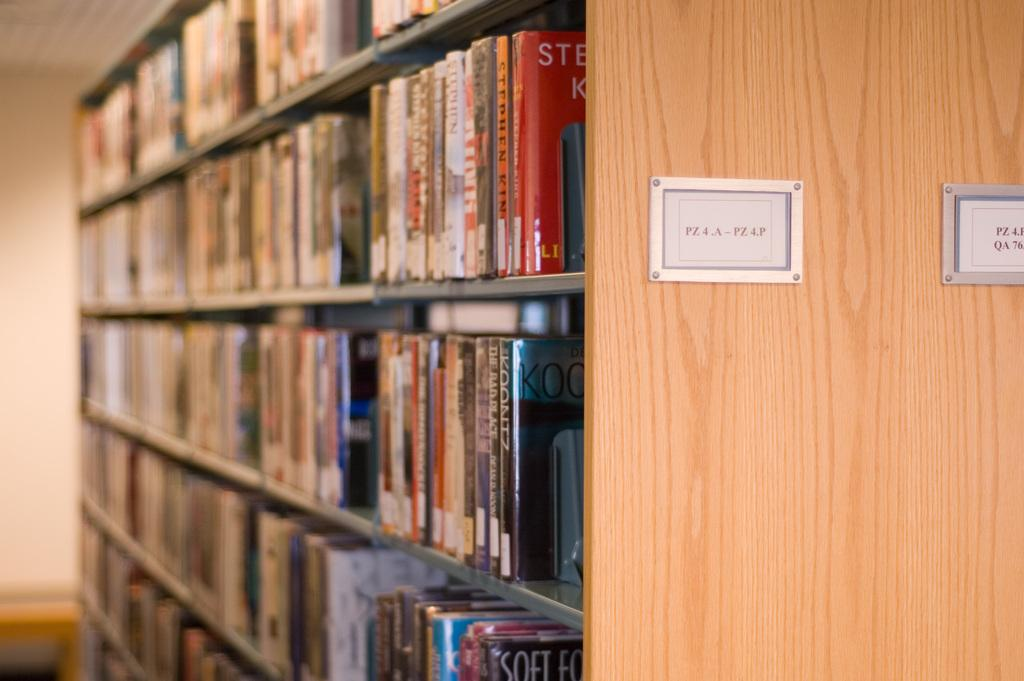What is the main subject of the image? The main subject of the image is a collection of books. How are the books arranged in the image? The books are placed in a rack. Are there any additional features attached to the wooden rack? Yes, there are two text boards attached to the wooden rack. How many bombs can be seen on the text boards in the image? There are no bombs present in the image; it only features books, a rack, and text boards. 